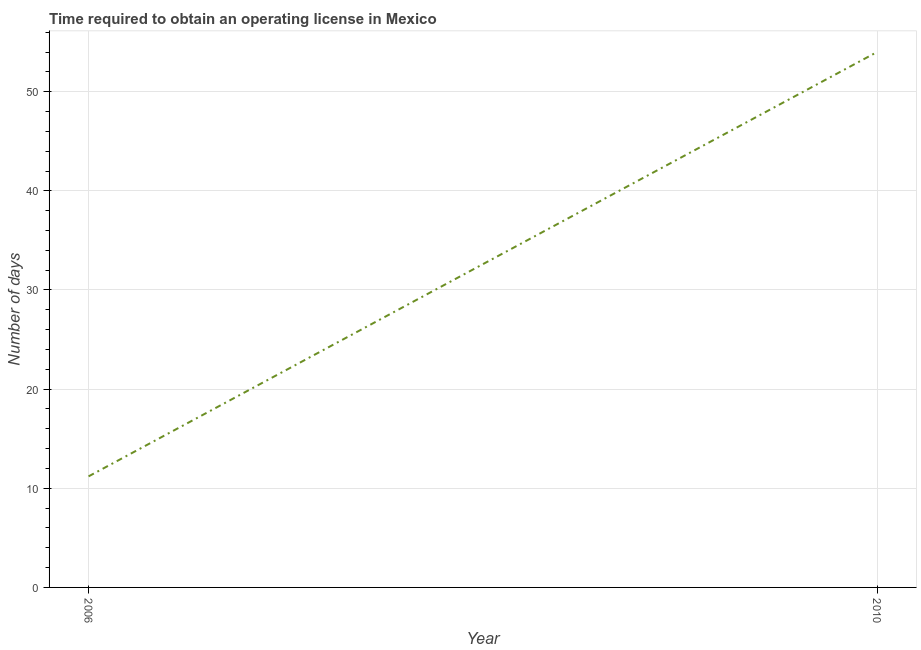What is the number of days to obtain operating license in 2006?
Your answer should be very brief. 11.2. Across all years, what is the maximum number of days to obtain operating license?
Make the answer very short. 54. Across all years, what is the minimum number of days to obtain operating license?
Offer a terse response. 11.2. In which year was the number of days to obtain operating license maximum?
Give a very brief answer. 2010. In which year was the number of days to obtain operating license minimum?
Ensure brevity in your answer.  2006. What is the sum of the number of days to obtain operating license?
Your answer should be compact. 65.2. What is the difference between the number of days to obtain operating license in 2006 and 2010?
Your answer should be compact. -42.8. What is the average number of days to obtain operating license per year?
Keep it short and to the point. 32.6. What is the median number of days to obtain operating license?
Give a very brief answer. 32.6. Do a majority of the years between 2010 and 2006 (inclusive) have number of days to obtain operating license greater than 10 days?
Give a very brief answer. No. What is the ratio of the number of days to obtain operating license in 2006 to that in 2010?
Offer a very short reply. 0.21. Does the number of days to obtain operating license monotonically increase over the years?
Offer a terse response. Yes. How many years are there in the graph?
Make the answer very short. 2. Are the values on the major ticks of Y-axis written in scientific E-notation?
Offer a very short reply. No. What is the title of the graph?
Provide a short and direct response. Time required to obtain an operating license in Mexico. What is the label or title of the Y-axis?
Provide a short and direct response. Number of days. What is the Number of days in 2010?
Your answer should be compact. 54. What is the difference between the Number of days in 2006 and 2010?
Offer a terse response. -42.8. What is the ratio of the Number of days in 2006 to that in 2010?
Your answer should be very brief. 0.21. 